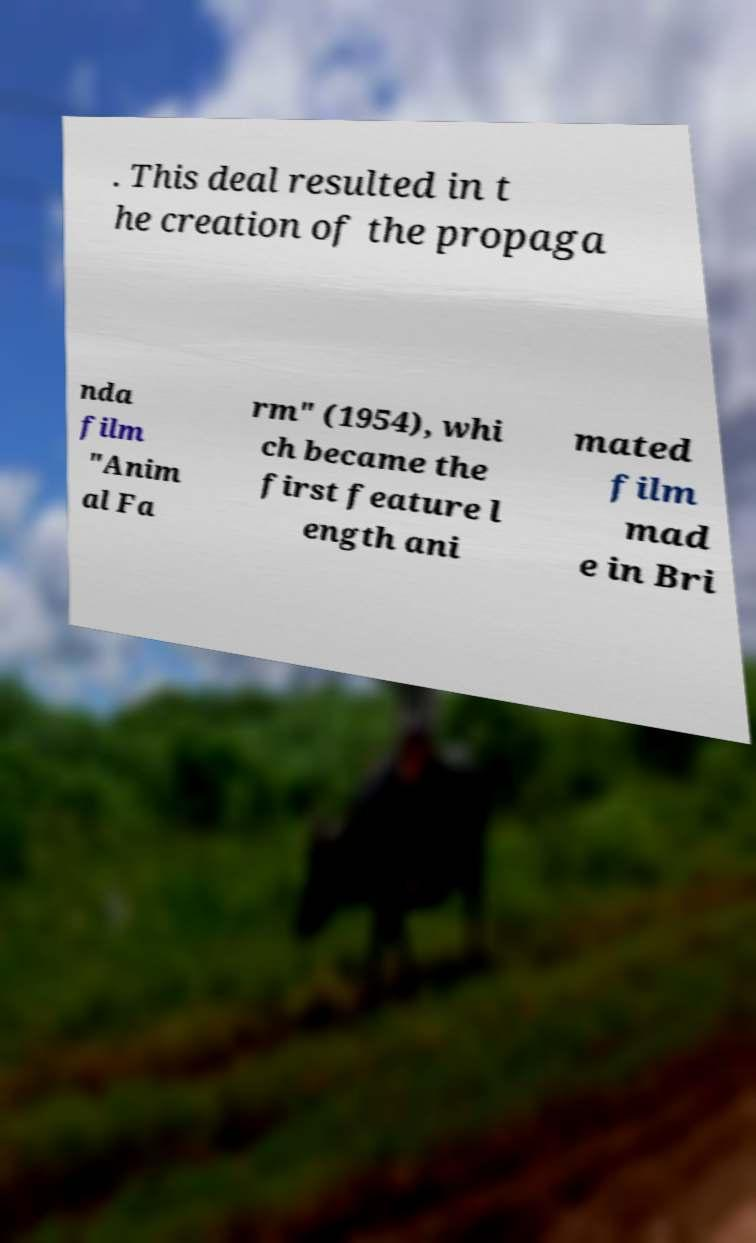Can you read and provide the text displayed in the image?This photo seems to have some interesting text. Can you extract and type it out for me? . This deal resulted in t he creation of the propaga nda film "Anim al Fa rm" (1954), whi ch became the first feature l ength ani mated film mad e in Bri 